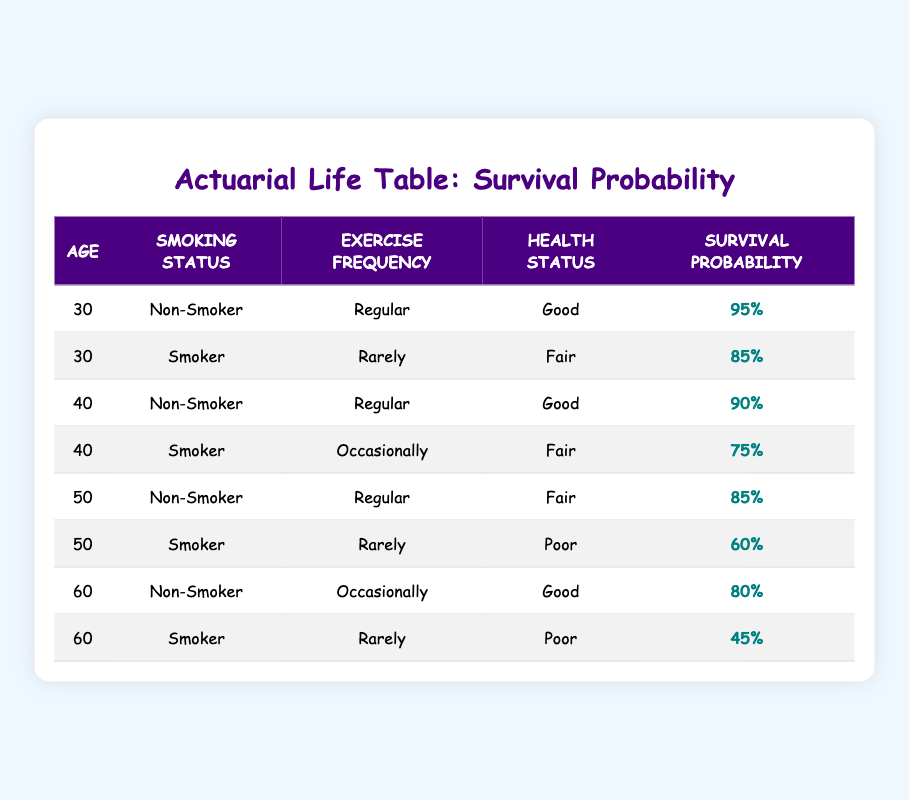What is the survival probability for a 30-year-old non-smoker who exercises regularly? Referring to the table, for a 30-year-old non-smoker with regular exercise, the survival probability is directly listed as 95%.
Answer: 95% What is the survival probability for a 50-year-old smoker who exercises rarely? For a 50-year-old smoker who exercises rarely, the table shows a survival probability of 60%.
Answer: 60% Is the survival probability higher for non-smokers or smokers at age 40? At age 40, the survival probability for non-smokers is 90%, while for smokers, it is 75%. Since 90% is higher than 75%, the survival probability is higher for non-smokers.
Answer: Yes What is the average survival probability for individuals aged 60? The survival probabilities for individuals aged 60 are 80% for non-smokers and 45% for smokers, totaling 125%. To find the average, divide by the number of data points (2), so the average is 125% / 2 = 62.5%.
Answer: 62.5% Is there any 50-year-old individual in the table with a survival probability of at least 80%? For 50-year-olds, the survival probabilities listed are 85% for non-smokers and 60% for smokers. Since 85% is at least 80%, there is indeed a 50-year-old with a survival probability of at least 80%.
Answer: Yes How does the survival probability of a 40-year-old non-smoker compare to that of a 60-year-old non-smoker? The survival probability for a 40-year-old non-smoker is 90%, while for a 60-year-old non-smoker, it is 80%. Therefore, 90% is greater than 80%, indicating that the 40-year-old non-smoker has a higher survival probability than the 60-year-old non-smoker.
Answer: 90% is greater than 80% What is the total number of individuals listed in the table with a survival probability below 70%? The only individual with a survival probability below 70% is the 60-year-old smoker with a survival probability of 45%. Therefore, there is 1 individual with a survival probability below 70%.
Answer: 1 Which smoking status group has a better survival probability at age 50? For age 50, the survival probability is 85% for non-smokers and 60% for smokers. Since 85% is higher than 60%, non-smokers have a better survival probability at age 50.
Answer: Non-smokers What is the survival probability for a 60-year-old non-smoker who exercises occasionally? The table indicates that a 60-year-old non-smoker with occasional exercise has a survival probability of 80%.
Answer: 80% 